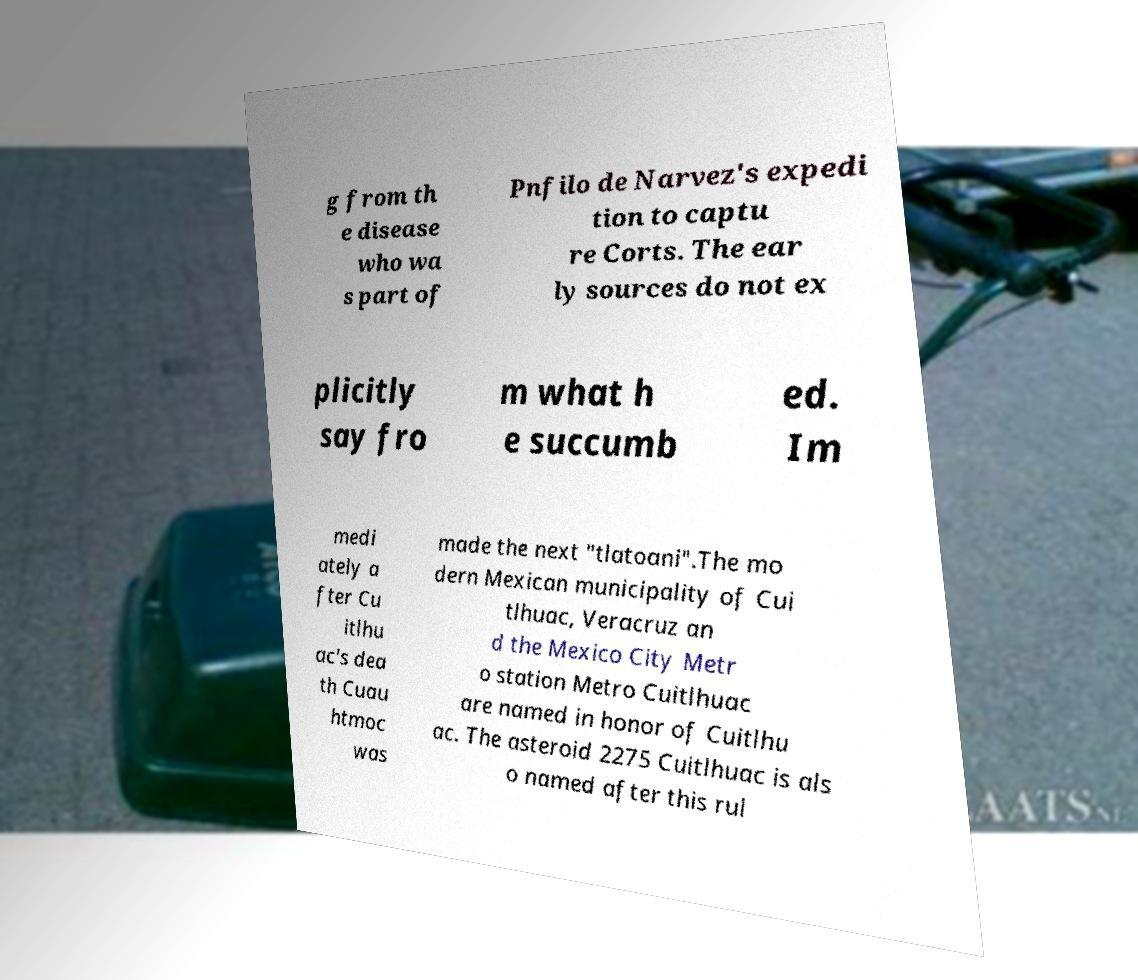Can you accurately transcribe the text from the provided image for me? g from th e disease who wa s part of Pnfilo de Narvez's expedi tion to captu re Corts. The ear ly sources do not ex plicitly say fro m what h e succumb ed. Im medi ately a fter Cu itlhu ac's dea th Cuau htmoc was made the next "tlatoani".The mo dern Mexican municipality of Cui tlhuac, Veracruz an d the Mexico City Metr o station Metro Cuitlhuac are named in honor of Cuitlhu ac. The asteroid 2275 Cuitlhuac is als o named after this rul 